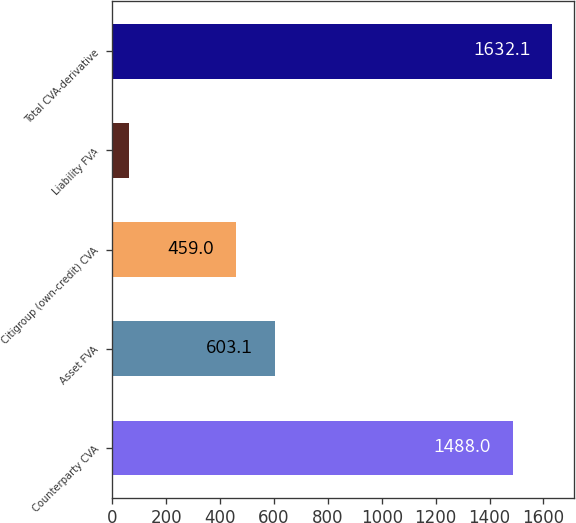Convert chart. <chart><loc_0><loc_0><loc_500><loc_500><bar_chart><fcel>Counterparty CVA<fcel>Asset FVA<fcel>Citigroup (own-credit) CVA<fcel>Liability FVA<fcel>Total CVA-derivative<nl><fcel>1488<fcel>603.1<fcel>459<fcel>62<fcel>1632.1<nl></chart> 